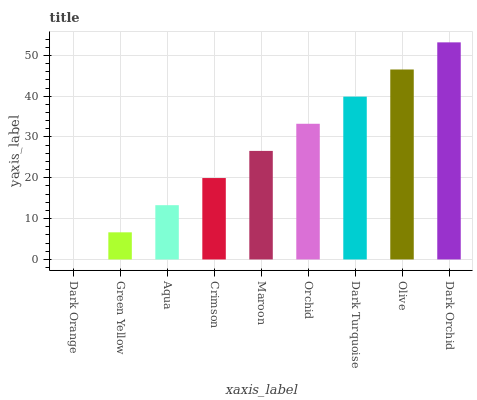Is Dark Orange the minimum?
Answer yes or no. Yes. Is Dark Orchid the maximum?
Answer yes or no. Yes. Is Green Yellow the minimum?
Answer yes or no. No. Is Green Yellow the maximum?
Answer yes or no. No. Is Green Yellow greater than Dark Orange?
Answer yes or no. Yes. Is Dark Orange less than Green Yellow?
Answer yes or no. Yes. Is Dark Orange greater than Green Yellow?
Answer yes or no. No. Is Green Yellow less than Dark Orange?
Answer yes or no. No. Is Maroon the high median?
Answer yes or no. Yes. Is Maroon the low median?
Answer yes or no. Yes. Is Crimson the high median?
Answer yes or no. No. Is Aqua the low median?
Answer yes or no. No. 